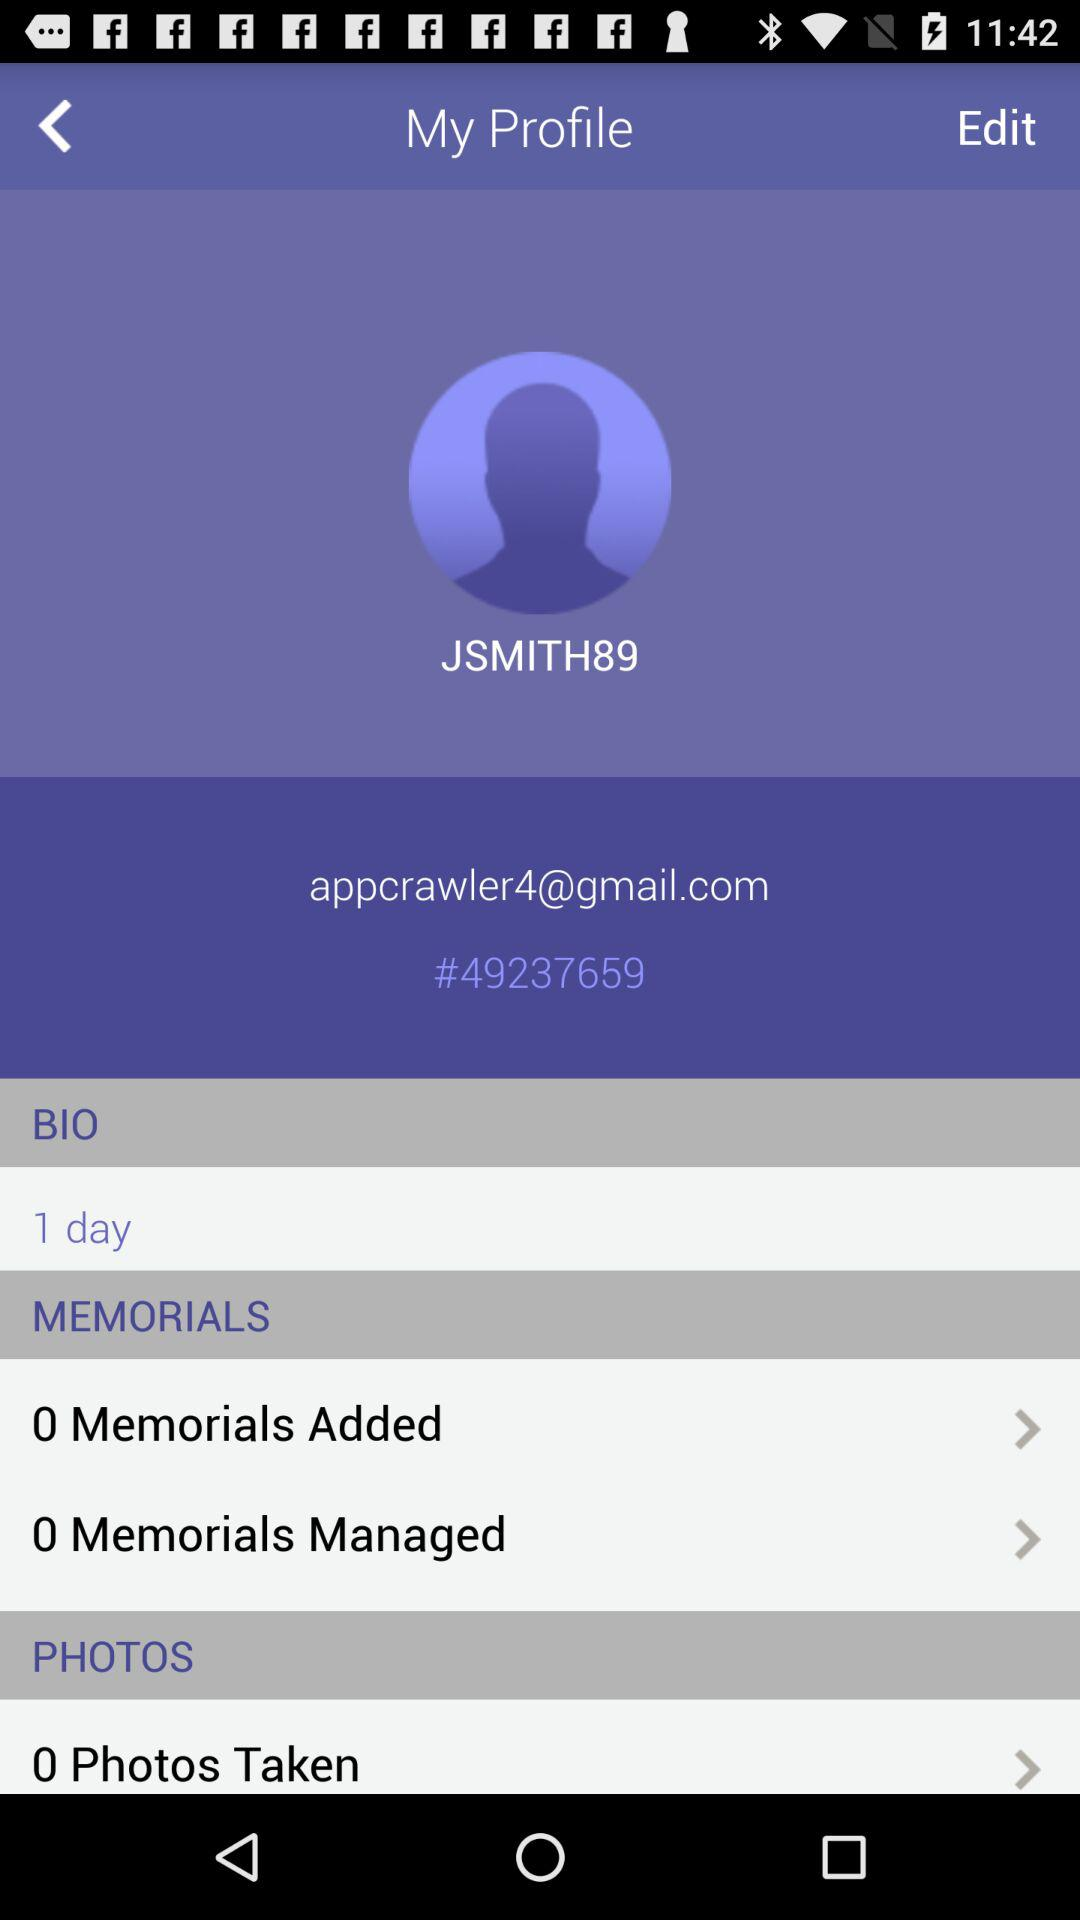How many photos were taken? There were 0 photos taken. 